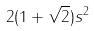Convert formula to latex. <formula><loc_0><loc_0><loc_500><loc_500>2 ( 1 + \sqrt { 2 } ) s ^ { 2 }</formula> 